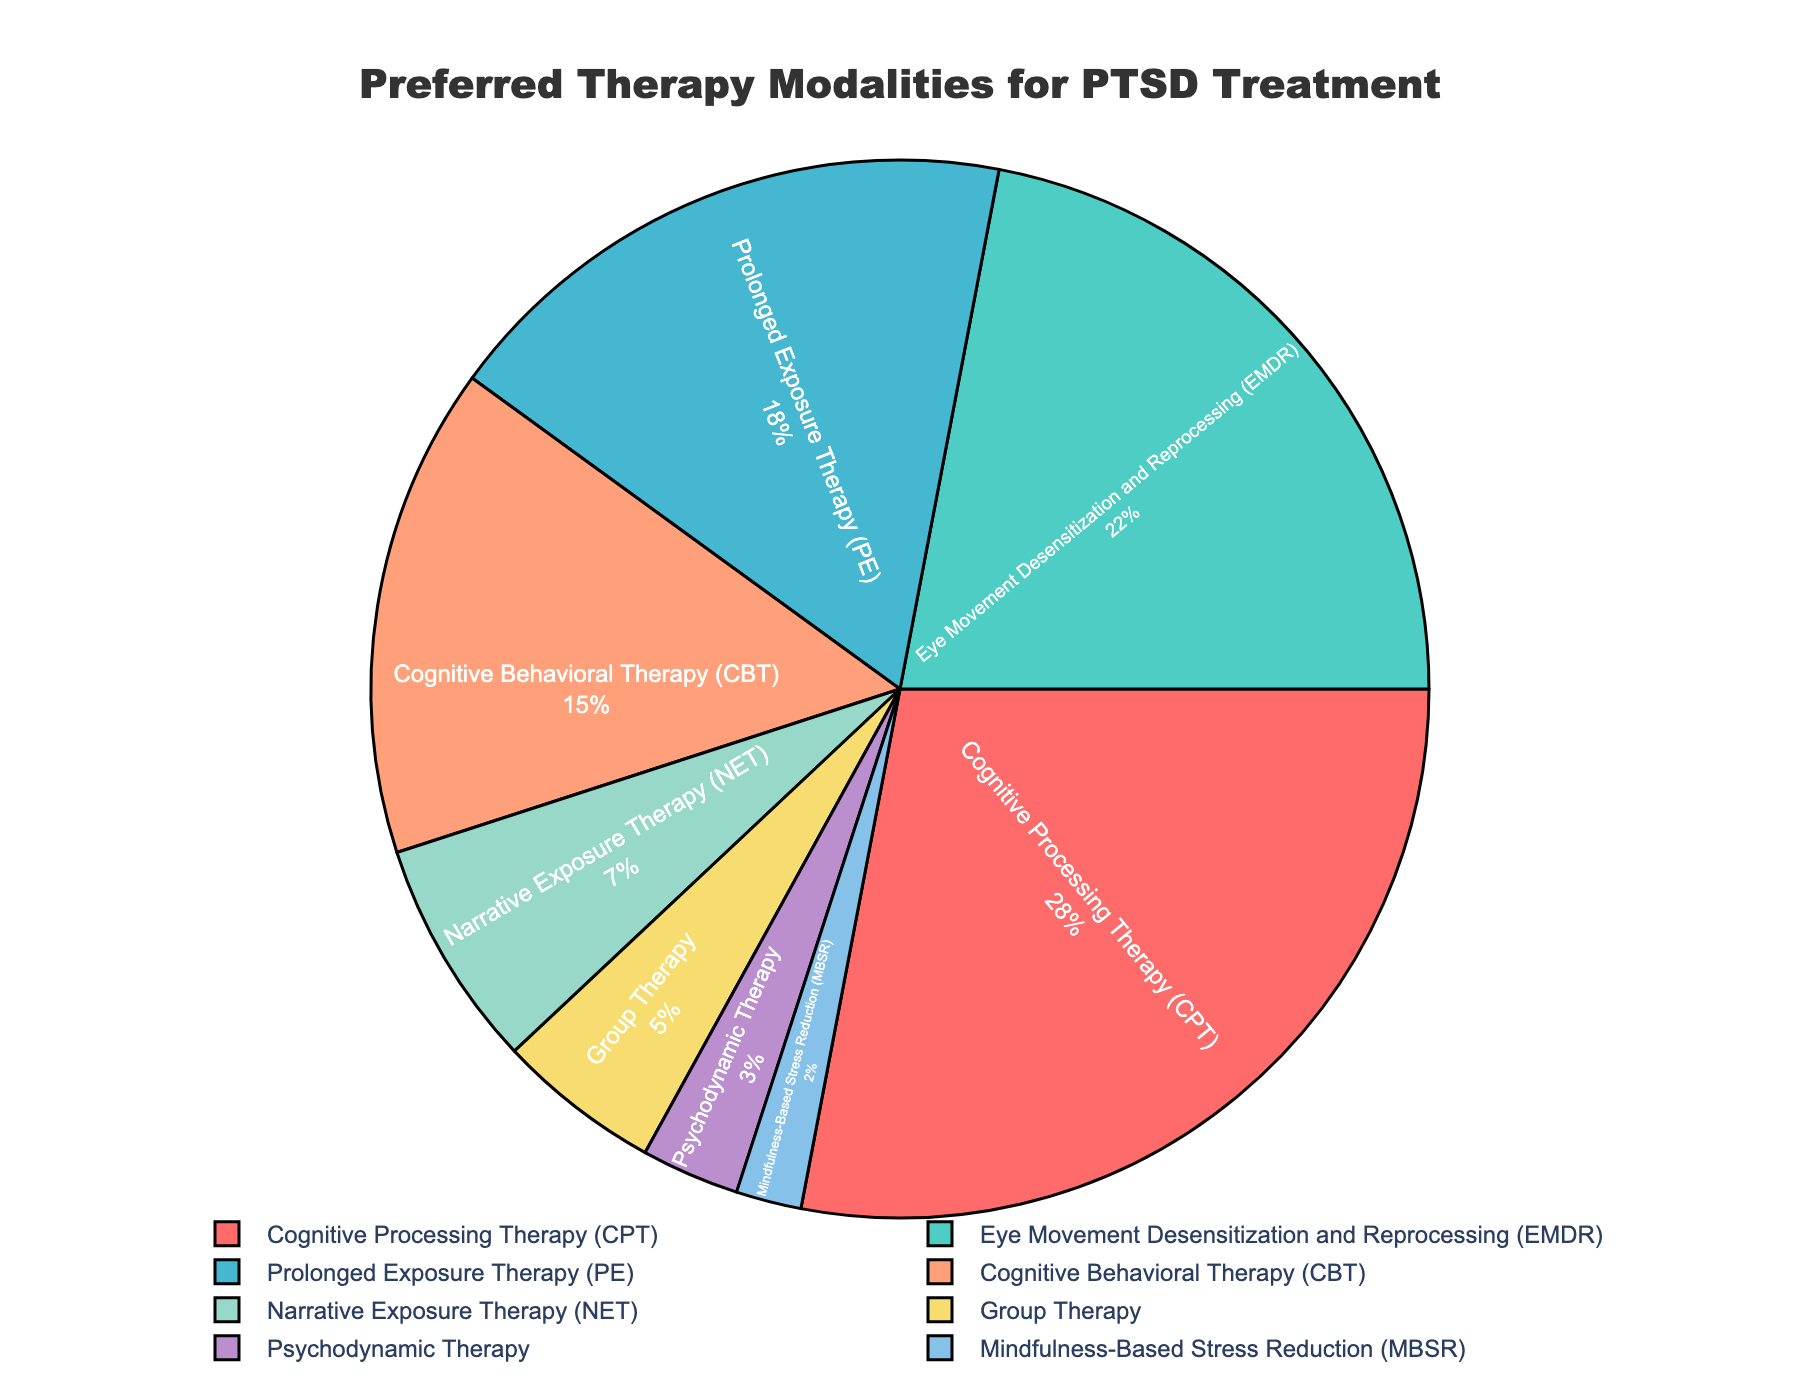What therapy modality has the highest preference for PTSD treatment? Identify the largest section in the pie chart. The largest section has the label "Cognitive Processing Therapy (CPT)" with 28%.
Answer: Cognitive Processing Therapy (CPT) Which therapy modality has the smallest preference for PTSD treatment? Identify the smallest section in the pie chart. The smallest section has the label "Mindfulness-Based Stress Reduction (MBSR)" with 2%.
Answer: Mindfulness-Based Stress Reduction (MBSR) What is the combined percentage of Cognitive Behavioral Therapy (CBT) and Eye Movement Desensitization and Reprocessing (EMDR)? Locate the sections labeled "Cognitive Behavioral Therapy (CBT)" and "Eye Movement Desensitization and Reprocessing (EMDR)". Sum their percentages: 15% + 22% = 37%.
Answer: 37% Which therapy modality has a higher preference, Group Therapy or Narrative Exposure Therapy (NET)? Compare the sizes of the sections labeled "Group Therapy" and "Narrative Exposure Therapy (NET)". Group Therapy has 5%, and NET has 7%. NET is higher.
Answer: Narrative Exposure Therapy (NET) How much higher is the preference for Prolonged Exposure Therapy (PE) than for Psychodynamic Therapy? Subtract the percentage of Psychodynamic Therapy (3%) from Prolonged Exposure Therapy (18%): 18% - 3% = 15%.
Answer: 15% Which two therapy modalities together account for exactly half of the preferences? Find sections that sum up to 50%. Cognitive Processing Therapy (28%) and Eye Movement Desensitization and Reprocessing (22%) together sum up to 28% + 22% = 50%.
Answer: Cognitive Processing Therapy (CPT) and Eye Movement Desensitization and Reprocessing (EMDR) What is the average preference percentage for the therapy modalities categorized? Sum all the percentages and divide by the number of categories: (28 + 22 + 18 + 15 + 7 + 5 + 3 + 2) / 8 = 100 / 8 = 12.5%.
Answer: 12.5% Is Cognitive Behavioral Therapy (CBT) preferred more than Prolonged Exposure Therapy (PE)? Compare the sections labeled "Cognitive Behavioral Therapy (CBT)" and "Prolonged Exposure Therapy (PE)". CBT has 15%, and PE has 18%. PE is preferred more.
Answer: No What is the total percentage for modalities other than Cognitive Processing Therapy and Eye Movement Desensitization and Reprocessing? Subtract the combined percentage of CPT and EMDR from 100%: 100% - (28% + 22%) = 100% - 50% = 50%.
Answer: 50% What color is the section representing Cognitive Processing Therapy (CPT)? Locate the section labeled "Cognitive Processing Therapy (CPT)" and identify its color. The color for CPT is red.
Answer: Red 